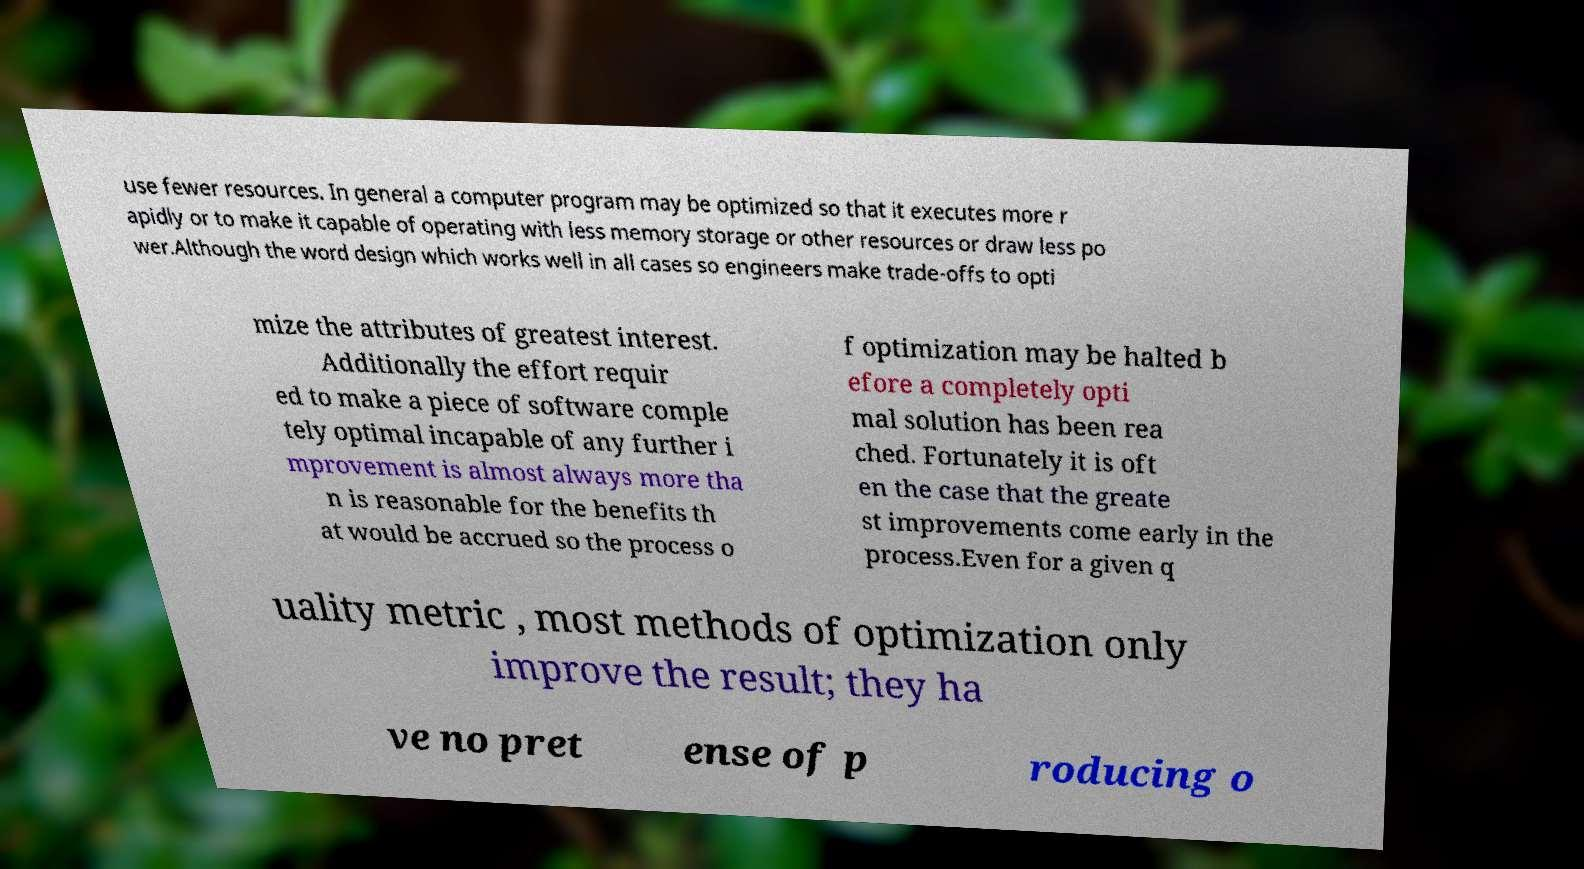I need the written content from this picture converted into text. Can you do that? use fewer resources. In general a computer program may be optimized so that it executes more r apidly or to make it capable of operating with less memory storage or other resources or draw less po wer.Although the word design which works well in all cases so engineers make trade-offs to opti mize the attributes of greatest interest. Additionally the effort requir ed to make a piece of software comple tely optimal incapable of any further i mprovement is almost always more tha n is reasonable for the benefits th at would be accrued so the process o f optimization may be halted b efore a completely opti mal solution has been rea ched. Fortunately it is oft en the case that the greate st improvements come early in the process.Even for a given q uality metric , most methods of optimization only improve the result; they ha ve no pret ense of p roducing o 